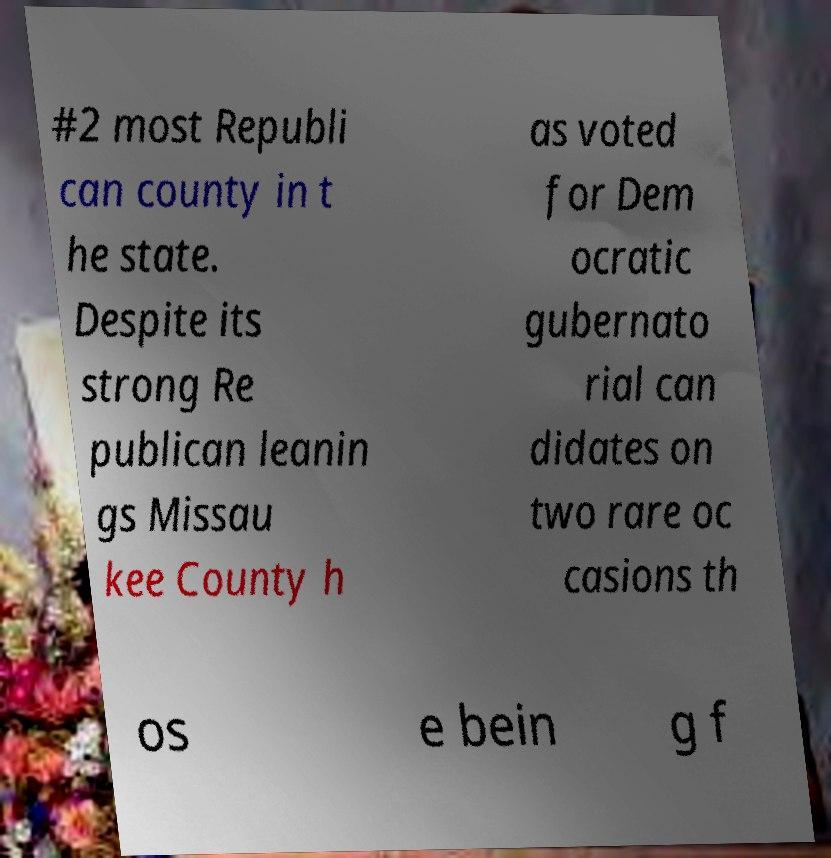I need the written content from this picture converted into text. Can you do that? #2 most Republi can county in t he state. Despite its strong Re publican leanin gs Missau kee County h as voted for Dem ocratic gubernato rial can didates on two rare oc casions th os e bein g f 